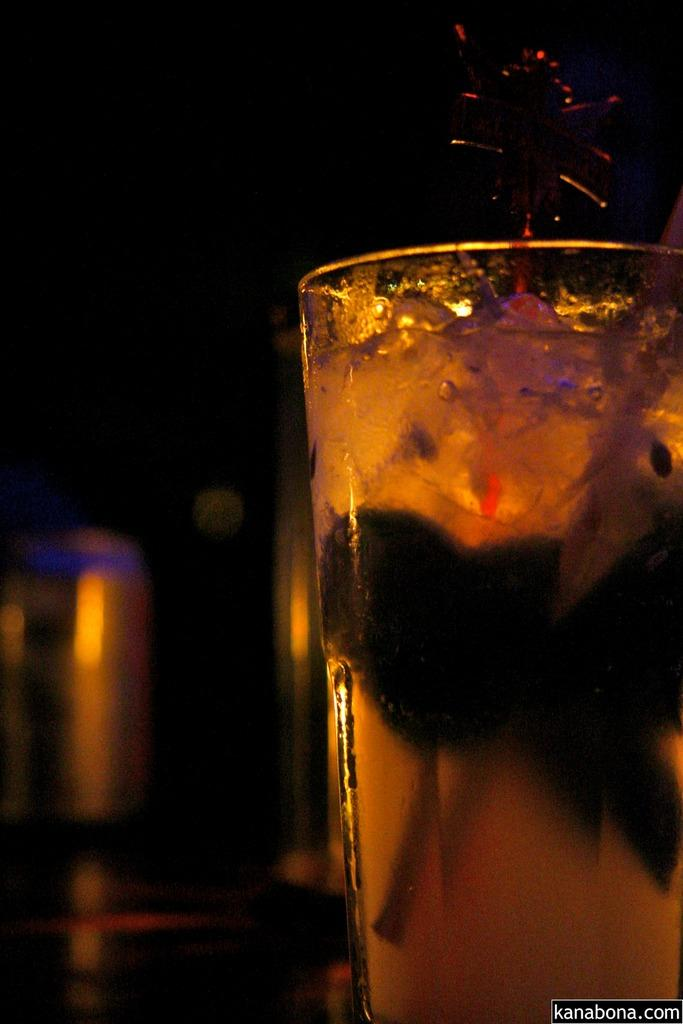What is in the glass that is visible in the image? The glass contains juice. What type of container is holding the juice in the image? There is a glass in the image. How many pigs are performing a joke in the image? There are no pigs or jokes present in the image. What type of trucks can be seen transporting juice in the image? There are no trucks visible in the image; it only shows a glass containing juice. 